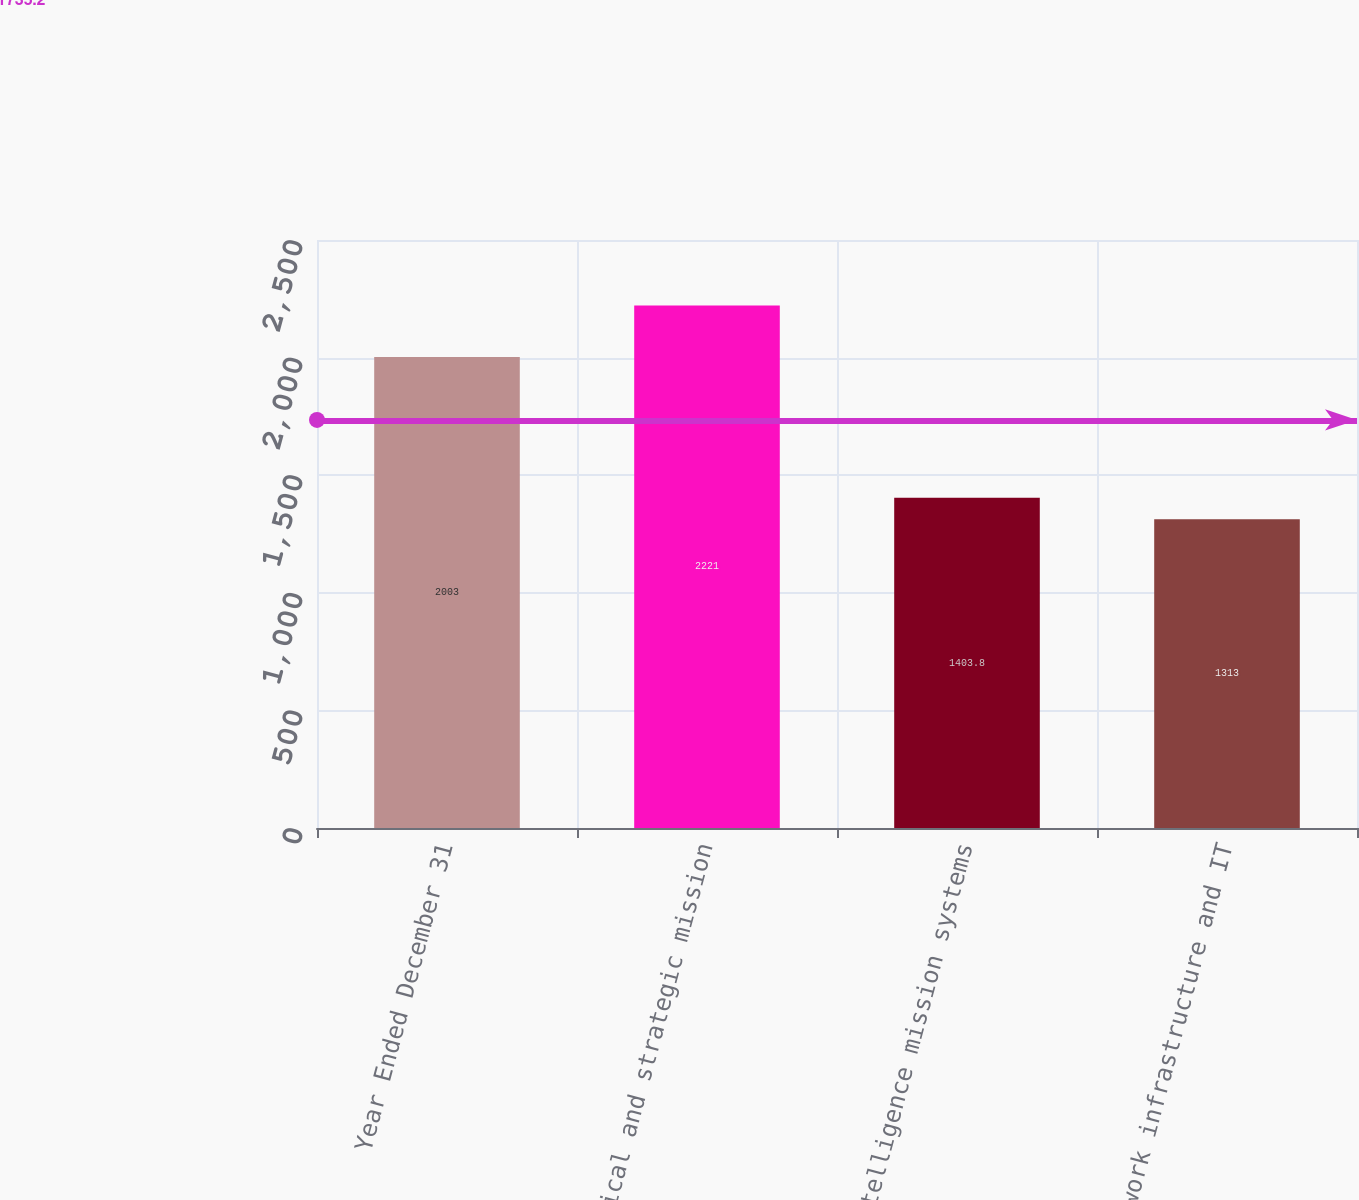Convert chart to OTSL. <chart><loc_0><loc_0><loc_500><loc_500><bar_chart><fcel>Year Ended December 31<fcel>Tactical and strategic mission<fcel>Intelligence mission systems<fcel>Network infrastructure and IT<nl><fcel>2003<fcel>2221<fcel>1403.8<fcel>1313<nl></chart> 